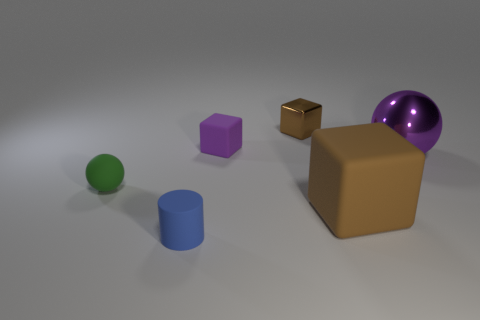What is the size of the rubber block that is the same color as the big metallic sphere?
Offer a terse response. Small. What is the small brown cube made of?
Give a very brief answer. Metal. There is a metal thing that is the same size as the blue rubber object; what color is it?
Provide a succinct answer. Brown. There is a metal thing that is the same color as the big rubber object; what shape is it?
Provide a short and direct response. Cube. Is the shape of the tiny purple rubber object the same as the big purple shiny object?
Offer a terse response. No. What is the material of the small object that is both in front of the large purple ball and behind the small blue cylinder?
Offer a terse response. Rubber. What is the size of the green rubber object?
Give a very brief answer. Small. There is a tiny metal object that is the same shape as the large brown thing; what is its color?
Keep it short and to the point. Brown. Are there any other things that have the same color as the small shiny object?
Keep it short and to the point. Yes. There is a metallic object that is on the right side of the large brown cube; is its size the same as the rubber cube to the left of the tiny brown metallic cube?
Keep it short and to the point. No. 